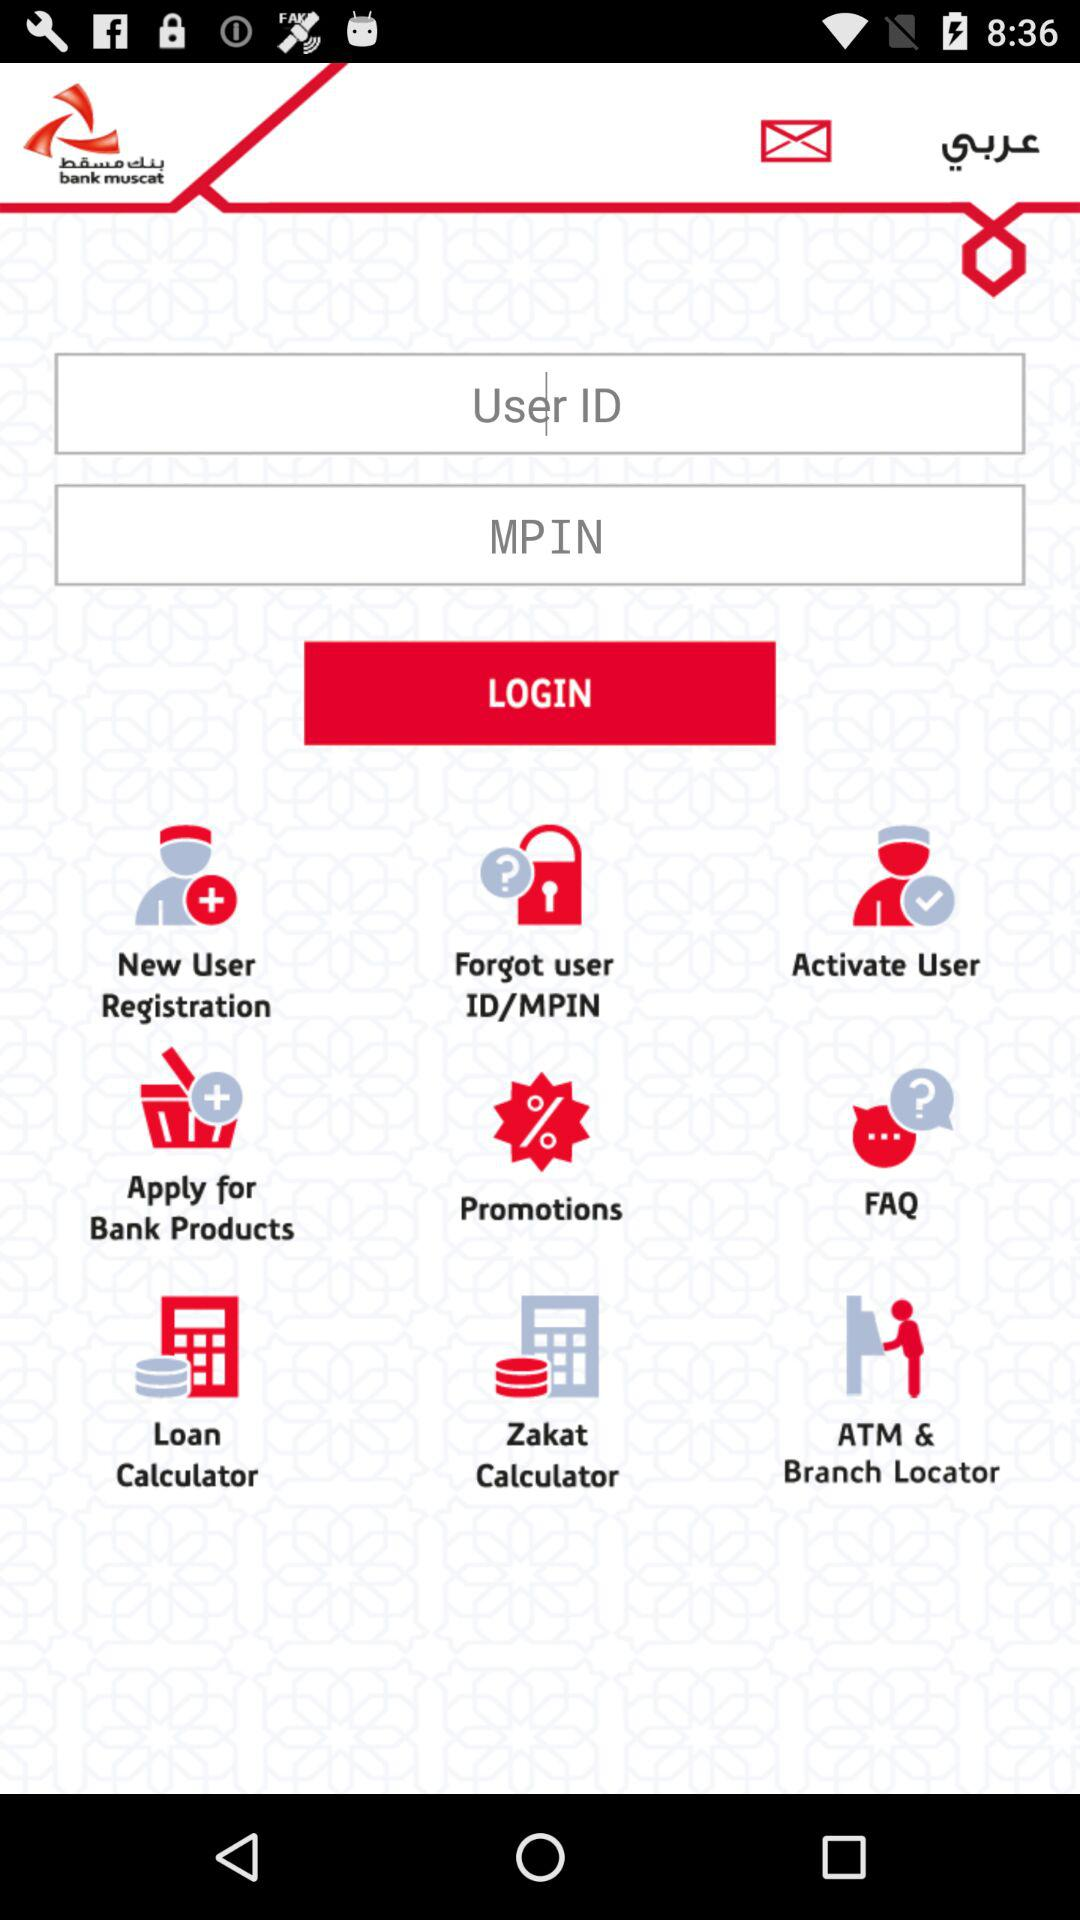What is the name of the application? The name of the application is "bank muscat". 